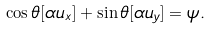<formula> <loc_0><loc_0><loc_500><loc_500>\cos \theta [ \alpha u _ { x } ] + \sin \theta [ \alpha u _ { y } ] = \psi .</formula> 